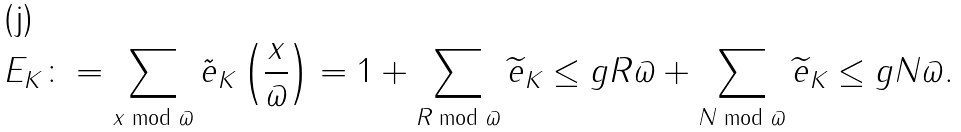<formula> <loc_0><loc_0><loc_500><loc_500>E _ { K } \colon = \sum _ { x \bmod \varpi } \tilde { e } _ { K } \left ( \frac { x } { \varpi } \right ) = 1 + \sum _ { R \bmod { \varpi } } \widetilde { e } _ { K } \leq g { R } { \varpi } + \sum _ { N \bmod { \varpi } } \widetilde { e } _ { K } \leq g { N } { \varpi } .</formula> 